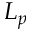<formula> <loc_0><loc_0><loc_500><loc_500>L _ { p }</formula> 